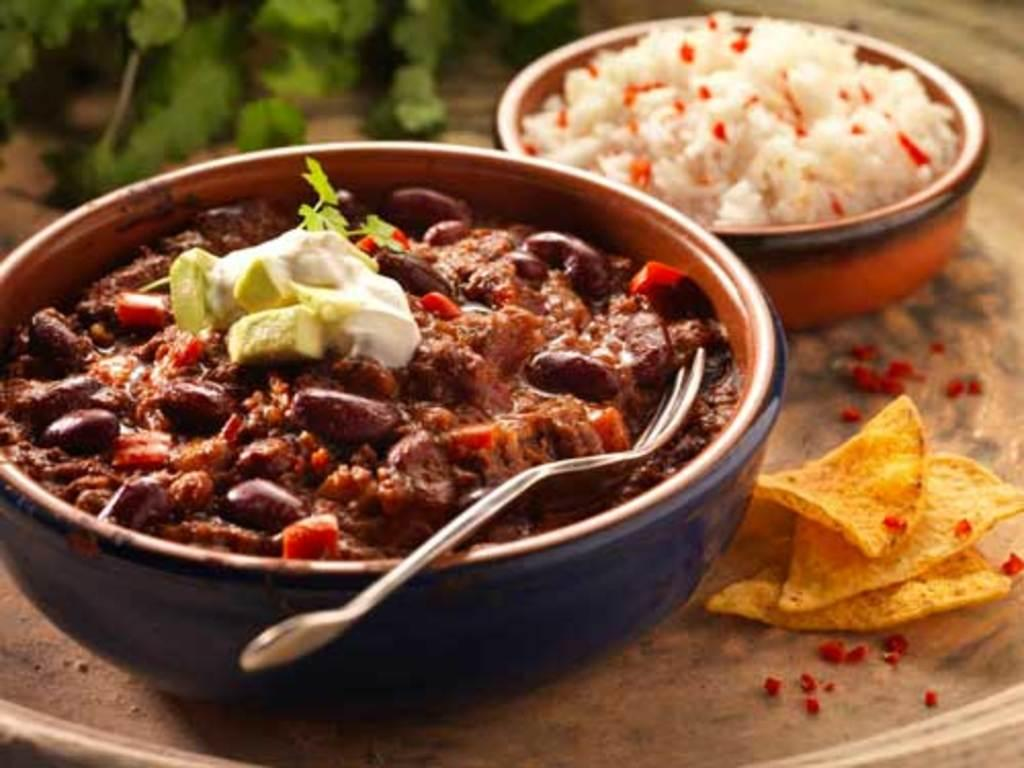What is in the bowl that is visible in the image? There is a bowl with curry, cream, and a leaf in the image. What utensil is present in the image? There is a fork in the image. Where is the bowl located? The bowl is on a table. What other food items can be seen on the table? There are chips and another bowl with rice on the table. What else is present on the table besides food items? There are leaves on the table. What type of gate is visible in the image? There is no gate present in the image. How many brothers are visible in the image? There are no people, including brothers, present in the image. 